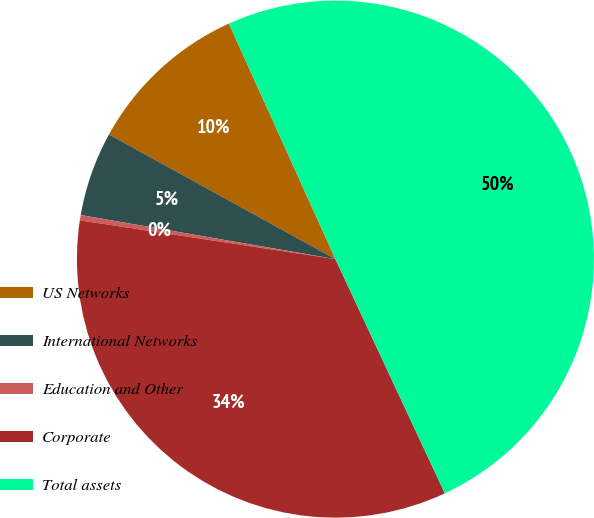Convert chart to OTSL. <chart><loc_0><loc_0><loc_500><loc_500><pie_chart><fcel>US Networks<fcel>International Networks<fcel>Education and Other<fcel>Corporate<fcel>Total assets<nl><fcel>10.23%<fcel>5.28%<fcel>0.33%<fcel>34.35%<fcel>49.8%<nl></chart> 